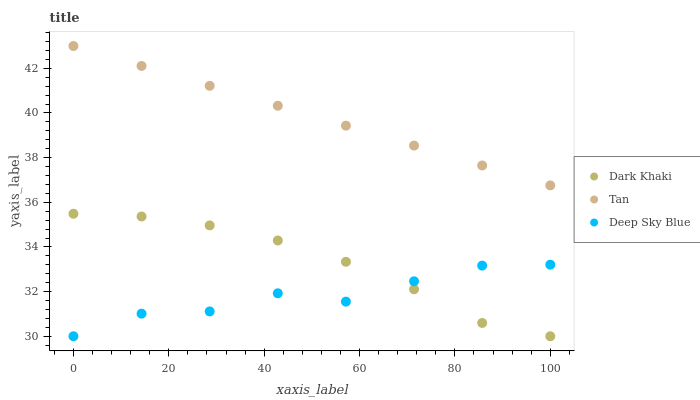Does Deep Sky Blue have the minimum area under the curve?
Answer yes or no. Yes. Does Tan have the maximum area under the curve?
Answer yes or no. Yes. Does Tan have the minimum area under the curve?
Answer yes or no. No. Does Deep Sky Blue have the maximum area under the curve?
Answer yes or no. No. Is Tan the smoothest?
Answer yes or no. Yes. Is Deep Sky Blue the roughest?
Answer yes or no. Yes. Is Deep Sky Blue the smoothest?
Answer yes or no. No. Is Tan the roughest?
Answer yes or no. No. Does Dark Khaki have the lowest value?
Answer yes or no. Yes. Does Tan have the lowest value?
Answer yes or no. No. Does Tan have the highest value?
Answer yes or no. Yes. Does Deep Sky Blue have the highest value?
Answer yes or no. No. Is Dark Khaki less than Tan?
Answer yes or no. Yes. Is Tan greater than Dark Khaki?
Answer yes or no. Yes. Does Deep Sky Blue intersect Dark Khaki?
Answer yes or no. Yes. Is Deep Sky Blue less than Dark Khaki?
Answer yes or no. No. Is Deep Sky Blue greater than Dark Khaki?
Answer yes or no. No. Does Dark Khaki intersect Tan?
Answer yes or no. No. 